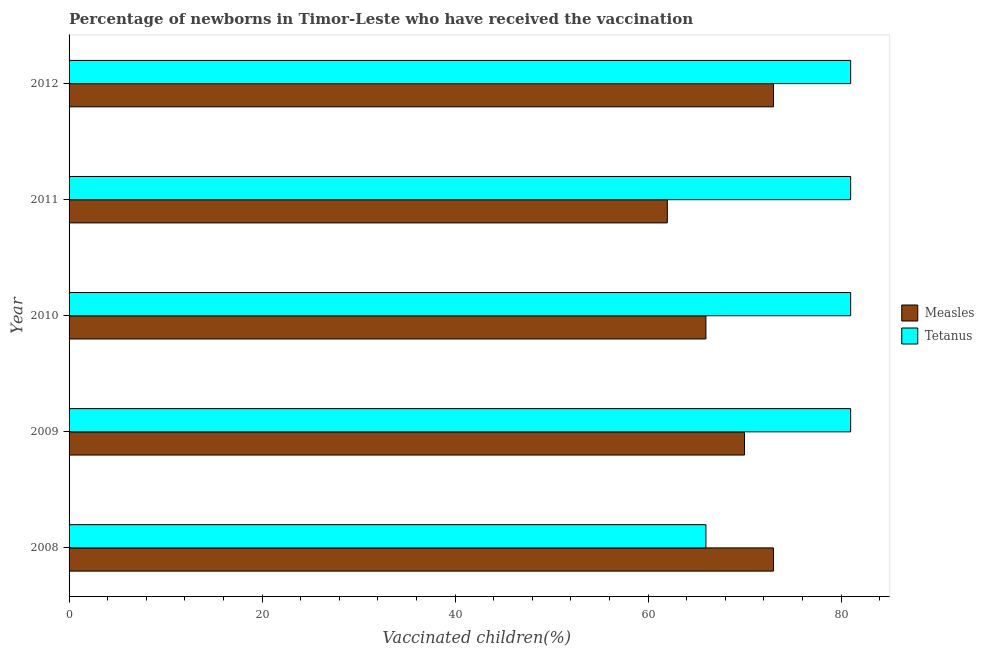How many different coloured bars are there?
Your answer should be very brief. 2. Are the number of bars on each tick of the Y-axis equal?
Offer a very short reply. Yes. How many bars are there on the 4th tick from the top?
Keep it short and to the point. 2. How many bars are there on the 1st tick from the bottom?
Keep it short and to the point. 2. What is the label of the 1st group of bars from the top?
Offer a very short reply. 2012. In how many cases, is the number of bars for a given year not equal to the number of legend labels?
Your answer should be compact. 0. What is the percentage of newborns who received vaccination for tetanus in 2012?
Offer a very short reply. 81. Across all years, what is the maximum percentage of newborns who received vaccination for tetanus?
Give a very brief answer. 81. Across all years, what is the minimum percentage of newborns who received vaccination for tetanus?
Offer a terse response. 66. In which year was the percentage of newborns who received vaccination for tetanus minimum?
Make the answer very short. 2008. What is the total percentage of newborns who received vaccination for measles in the graph?
Your answer should be very brief. 344. What is the difference between the percentage of newborns who received vaccination for tetanus in 2008 and that in 2009?
Provide a short and direct response. -15. What is the difference between the percentage of newborns who received vaccination for measles in 2008 and the percentage of newborns who received vaccination for tetanus in 2009?
Give a very brief answer. -8. In the year 2009, what is the difference between the percentage of newborns who received vaccination for measles and percentage of newborns who received vaccination for tetanus?
Give a very brief answer. -11. What is the ratio of the percentage of newborns who received vaccination for tetanus in 2008 to that in 2012?
Your response must be concise. 0.81. Is the percentage of newborns who received vaccination for tetanus in 2010 less than that in 2012?
Offer a very short reply. No. What is the difference between the highest and the lowest percentage of newborns who received vaccination for measles?
Ensure brevity in your answer.  11. Is the sum of the percentage of newborns who received vaccination for measles in 2008 and 2010 greater than the maximum percentage of newborns who received vaccination for tetanus across all years?
Offer a very short reply. Yes. What does the 1st bar from the top in 2012 represents?
Keep it short and to the point. Tetanus. What does the 1st bar from the bottom in 2010 represents?
Offer a very short reply. Measles. Are all the bars in the graph horizontal?
Provide a short and direct response. Yes. What is the difference between two consecutive major ticks on the X-axis?
Keep it short and to the point. 20. Does the graph contain any zero values?
Ensure brevity in your answer.  No. Does the graph contain grids?
Give a very brief answer. No. Where does the legend appear in the graph?
Offer a terse response. Center right. How many legend labels are there?
Give a very brief answer. 2. How are the legend labels stacked?
Your answer should be very brief. Vertical. What is the title of the graph?
Your answer should be compact. Percentage of newborns in Timor-Leste who have received the vaccination. What is the label or title of the X-axis?
Provide a short and direct response. Vaccinated children(%)
. What is the Vaccinated children(%)
 of Measles in 2009?
Provide a succinct answer. 70. What is the Vaccinated children(%)
 in Measles in 2010?
Your response must be concise. 66. What is the Vaccinated children(%)
 in Tetanus in 2011?
Ensure brevity in your answer.  81. What is the Vaccinated children(%)
 of Measles in 2012?
Offer a very short reply. 73. Across all years, what is the maximum Vaccinated children(%)
 of Measles?
Offer a very short reply. 73. Across all years, what is the minimum Vaccinated children(%)
 in Measles?
Provide a short and direct response. 62. What is the total Vaccinated children(%)
 of Measles in the graph?
Provide a short and direct response. 344. What is the total Vaccinated children(%)
 of Tetanus in the graph?
Make the answer very short. 390. What is the difference between the Vaccinated children(%)
 of Measles in 2008 and that in 2009?
Offer a very short reply. 3. What is the difference between the Vaccinated children(%)
 in Measles in 2008 and that in 2011?
Your response must be concise. 11. What is the difference between the Vaccinated children(%)
 in Tetanus in 2008 and that in 2011?
Your answer should be very brief. -15. What is the difference between the Vaccinated children(%)
 of Measles in 2008 and that in 2012?
Keep it short and to the point. 0. What is the difference between the Vaccinated children(%)
 in Tetanus in 2009 and that in 2010?
Keep it short and to the point. 0. What is the difference between the Vaccinated children(%)
 of Measles in 2009 and that in 2011?
Offer a terse response. 8. What is the difference between the Vaccinated children(%)
 in Tetanus in 2009 and that in 2011?
Ensure brevity in your answer.  0. What is the difference between the Vaccinated children(%)
 in Measles in 2009 and that in 2012?
Offer a very short reply. -3. What is the difference between the Vaccinated children(%)
 in Measles in 2010 and that in 2011?
Give a very brief answer. 4. What is the difference between the Vaccinated children(%)
 of Tetanus in 2010 and that in 2012?
Provide a short and direct response. 0. What is the difference between the Vaccinated children(%)
 in Measles in 2011 and that in 2012?
Offer a very short reply. -11. What is the difference between the Vaccinated children(%)
 in Tetanus in 2011 and that in 2012?
Keep it short and to the point. 0. What is the difference between the Vaccinated children(%)
 in Measles in 2008 and the Vaccinated children(%)
 in Tetanus in 2009?
Provide a succinct answer. -8. What is the difference between the Vaccinated children(%)
 of Measles in 2008 and the Vaccinated children(%)
 of Tetanus in 2010?
Keep it short and to the point. -8. What is the difference between the Vaccinated children(%)
 of Measles in 2008 and the Vaccinated children(%)
 of Tetanus in 2011?
Make the answer very short. -8. What is the difference between the Vaccinated children(%)
 of Measles in 2008 and the Vaccinated children(%)
 of Tetanus in 2012?
Provide a succinct answer. -8. What is the difference between the Vaccinated children(%)
 of Measles in 2009 and the Vaccinated children(%)
 of Tetanus in 2010?
Provide a succinct answer. -11. What is the difference between the Vaccinated children(%)
 of Measles in 2010 and the Vaccinated children(%)
 of Tetanus in 2011?
Keep it short and to the point. -15. What is the difference between the Vaccinated children(%)
 of Measles in 2011 and the Vaccinated children(%)
 of Tetanus in 2012?
Provide a short and direct response. -19. What is the average Vaccinated children(%)
 in Measles per year?
Make the answer very short. 68.8. In the year 2010, what is the difference between the Vaccinated children(%)
 of Measles and Vaccinated children(%)
 of Tetanus?
Offer a very short reply. -15. In the year 2011, what is the difference between the Vaccinated children(%)
 of Measles and Vaccinated children(%)
 of Tetanus?
Keep it short and to the point. -19. What is the ratio of the Vaccinated children(%)
 in Measles in 2008 to that in 2009?
Your response must be concise. 1.04. What is the ratio of the Vaccinated children(%)
 in Tetanus in 2008 to that in 2009?
Your answer should be compact. 0.81. What is the ratio of the Vaccinated children(%)
 of Measles in 2008 to that in 2010?
Give a very brief answer. 1.11. What is the ratio of the Vaccinated children(%)
 in Tetanus in 2008 to that in 2010?
Your answer should be compact. 0.81. What is the ratio of the Vaccinated children(%)
 in Measles in 2008 to that in 2011?
Give a very brief answer. 1.18. What is the ratio of the Vaccinated children(%)
 in Tetanus in 2008 to that in 2011?
Provide a short and direct response. 0.81. What is the ratio of the Vaccinated children(%)
 in Measles in 2008 to that in 2012?
Offer a very short reply. 1. What is the ratio of the Vaccinated children(%)
 in Tetanus in 2008 to that in 2012?
Your response must be concise. 0.81. What is the ratio of the Vaccinated children(%)
 in Measles in 2009 to that in 2010?
Your answer should be very brief. 1.06. What is the ratio of the Vaccinated children(%)
 of Tetanus in 2009 to that in 2010?
Provide a succinct answer. 1. What is the ratio of the Vaccinated children(%)
 of Measles in 2009 to that in 2011?
Your answer should be compact. 1.13. What is the ratio of the Vaccinated children(%)
 in Tetanus in 2009 to that in 2011?
Provide a short and direct response. 1. What is the ratio of the Vaccinated children(%)
 of Measles in 2009 to that in 2012?
Your answer should be very brief. 0.96. What is the ratio of the Vaccinated children(%)
 in Measles in 2010 to that in 2011?
Your response must be concise. 1.06. What is the ratio of the Vaccinated children(%)
 in Measles in 2010 to that in 2012?
Make the answer very short. 0.9. What is the ratio of the Vaccinated children(%)
 in Measles in 2011 to that in 2012?
Provide a short and direct response. 0.85. What is the ratio of the Vaccinated children(%)
 of Tetanus in 2011 to that in 2012?
Your answer should be very brief. 1. What is the difference between the highest and the second highest Vaccinated children(%)
 of Measles?
Make the answer very short. 0. What is the difference between the highest and the second highest Vaccinated children(%)
 of Tetanus?
Give a very brief answer. 0. What is the difference between the highest and the lowest Vaccinated children(%)
 of Measles?
Offer a very short reply. 11. 